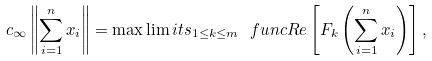Convert formula to latex. <formula><loc_0><loc_0><loc_500><loc_500>c _ { \infty } \left \| \sum _ { i = 1 } ^ { n } x _ { i } \right \| = \max \lim i t s _ { 1 \leq k \leq m } \ f u n c { R e } \left [ F _ { k } \left ( \sum _ { i = 1 } ^ { n } x _ { i } \right ) \right ] ,</formula> 